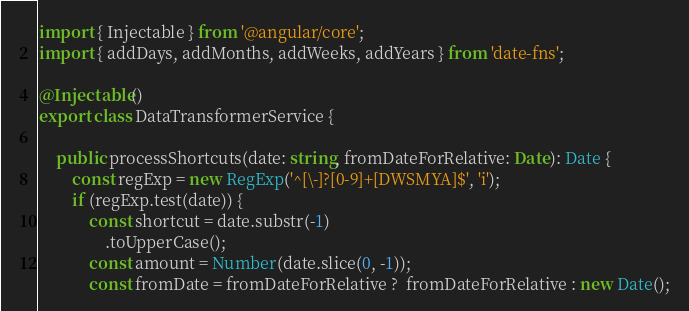Convert code to text. <code><loc_0><loc_0><loc_500><loc_500><_TypeScript_>import { Injectable } from '@angular/core';
import { addDays, addMonths, addWeeks, addYears } from 'date-fns';

@Injectable()
export class DataTransformerService {

	public processShortcuts(date: string, fromDateForRelative: Date): Date {
		const regExp = new RegExp('^[\-]?[0-9]+[DWSMYA]$', 'i');
		if (regExp.test(date)) {
			const shortcut = date.substr(-1)
				.toUpperCase();
			const amount = Number(date.slice(0, -1));
			const fromDate = fromDateForRelative ?  fromDateForRelative : new Date();</code> 